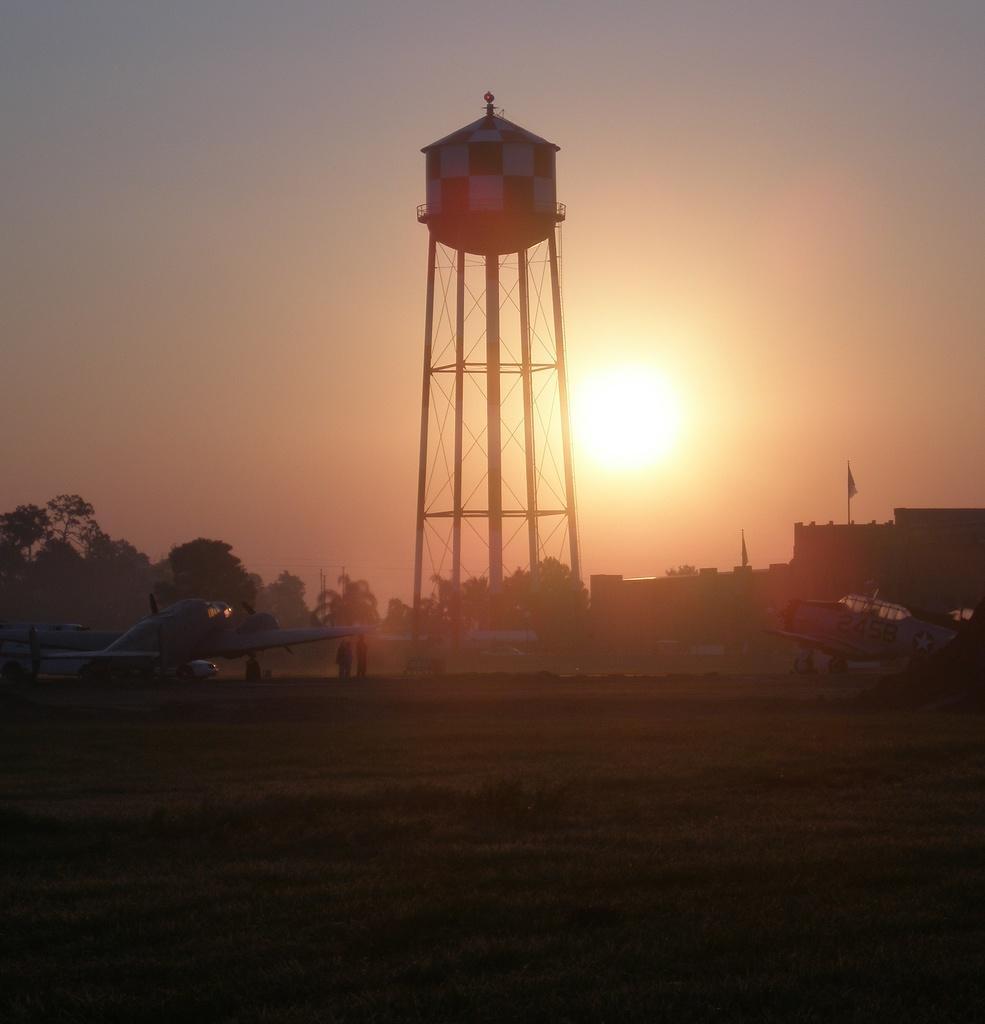Can you describe this image briefly? In this picture I can observe water tank in the middle of the picture. On the left side I can observe an airplane. In the background there are trees and sky. I can observe sun in the sky. 